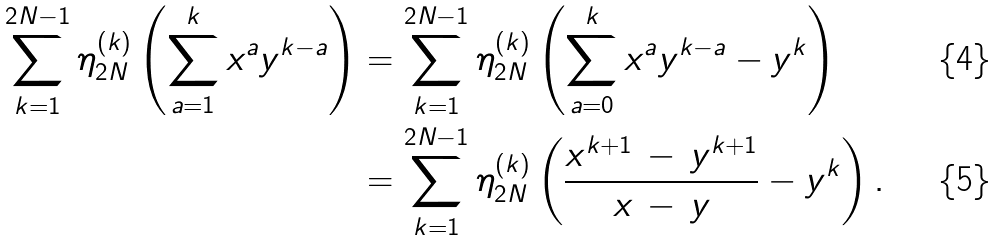<formula> <loc_0><loc_0><loc_500><loc_500>\sum _ { k = 1 } ^ { 2 N - 1 } \eta _ { 2 N } ^ { ( k ) } \left ( \sum _ { a = 1 } ^ { k } x ^ { a } y ^ { k - a } \right ) & = \sum _ { k = 1 } ^ { 2 N - 1 } \eta _ { 2 N } ^ { ( k ) } \left ( \sum _ { a = 0 } ^ { k } x ^ { a } y ^ { k - a } - y ^ { k } \right ) \\ & = \sum _ { k = 1 } ^ { 2 N - 1 } \eta _ { 2 N } ^ { ( k ) } \left ( \frac { x ^ { k + 1 } \, - \, y ^ { k + 1 } } { x \, - \, y } - y ^ { k } \right ) .</formula> 